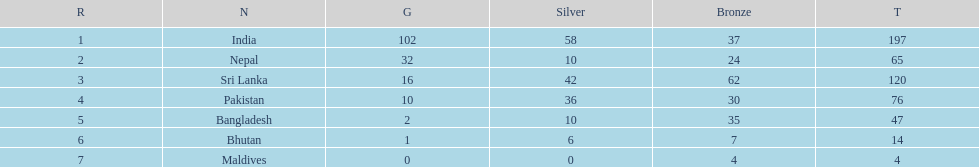What is the variation between the nation with the greatest quantity of medals and the nation with the least quantity of medals? 193. 